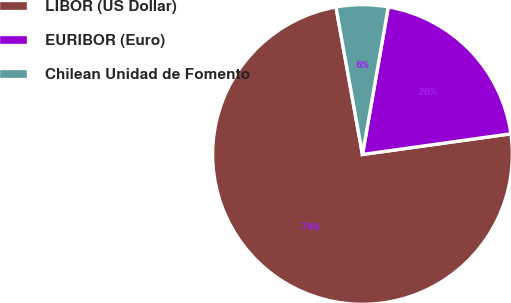Convert chart. <chart><loc_0><loc_0><loc_500><loc_500><pie_chart><fcel>LIBOR (US Dollar)<fcel>EURIBOR (Euro)<fcel>Chilean Unidad de Fomento<nl><fcel>74.37%<fcel>20.04%<fcel>5.59%<nl></chart> 